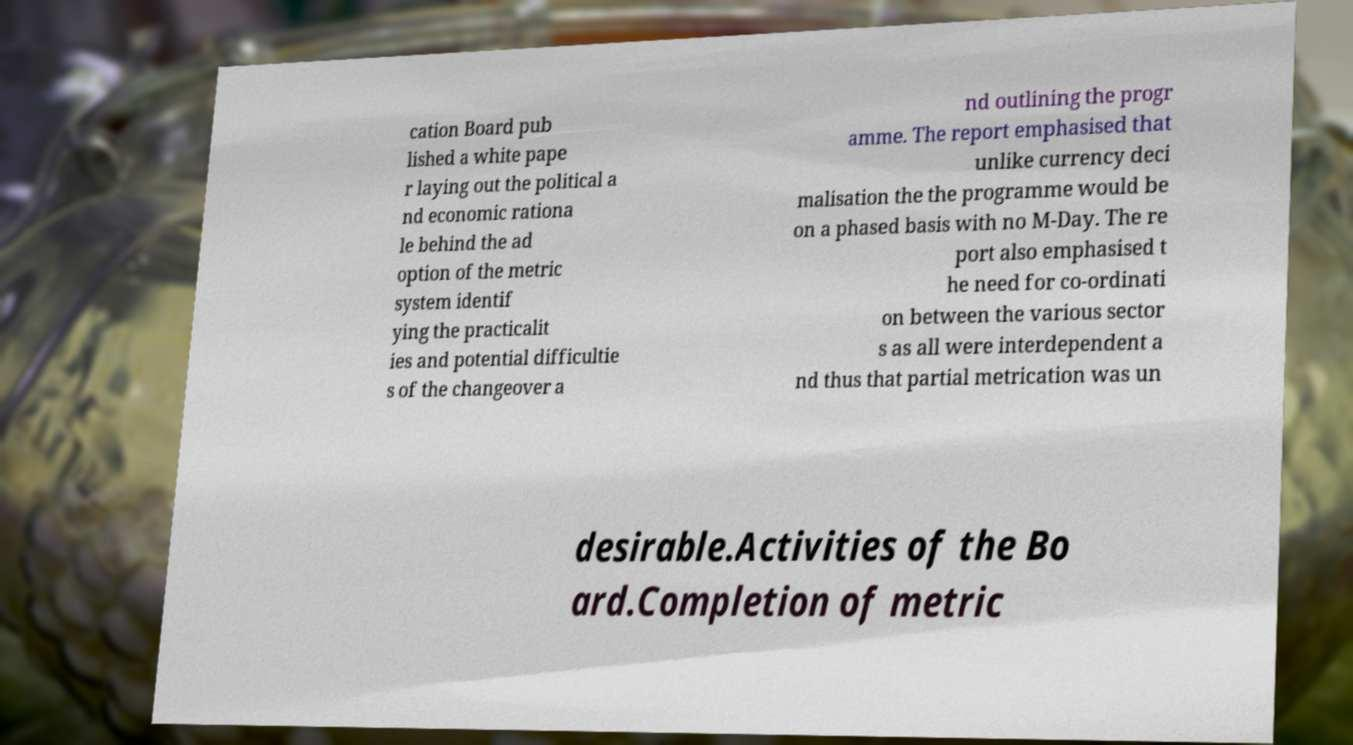What messages or text are displayed in this image? I need them in a readable, typed format. cation Board pub lished a white pape r laying out the political a nd economic rationa le behind the ad option of the metric system identif ying the practicalit ies and potential difficultie s of the changeover a nd outlining the progr amme. The report emphasised that unlike currency deci malisation the the programme would be on a phased basis with no M-Day. The re port also emphasised t he need for co-ordinati on between the various sector s as all were interdependent a nd thus that partial metrication was un desirable.Activities of the Bo ard.Completion of metric 